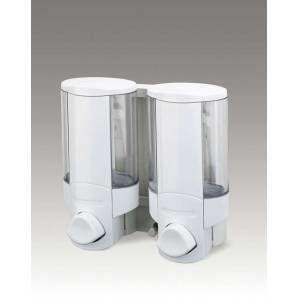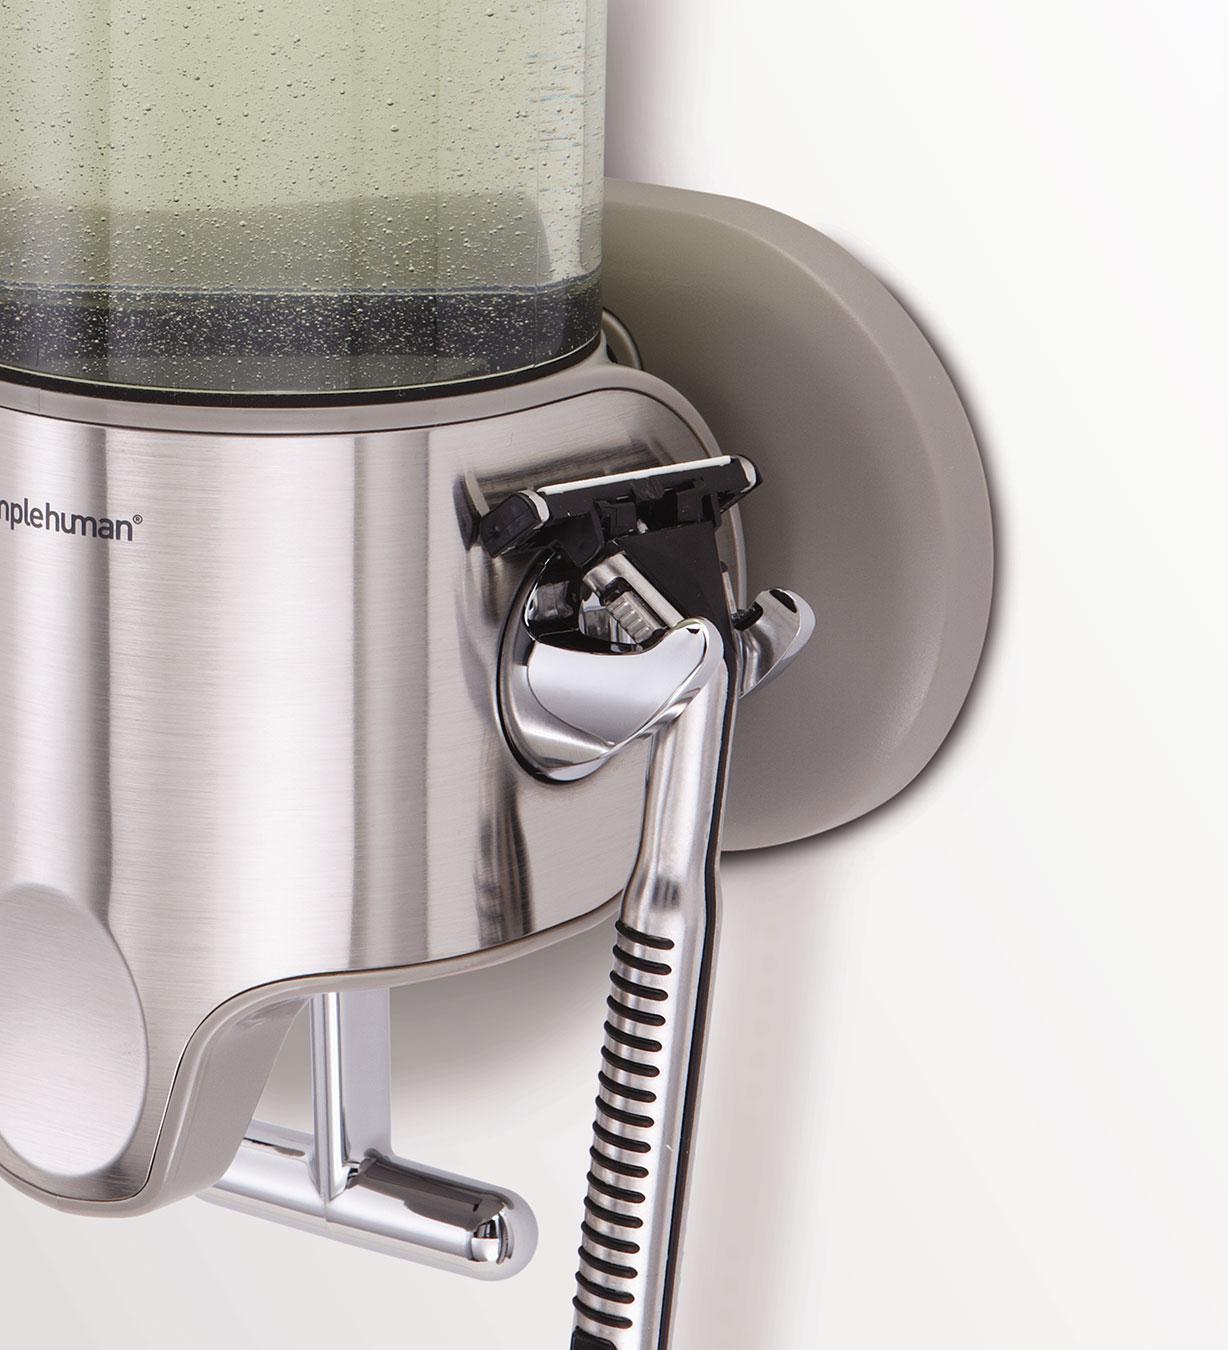The first image is the image on the left, the second image is the image on the right. Assess this claim about the two images: "There are four soap dispensers in total.". Correct or not? Answer yes or no. No. The first image is the image on the left, the second image is the image on the right. Considering the images on both sides, is "An image shows at least two side-by-side dispensers that feature a chrome T-shaped bar underneath." valid? Answer yes or no. No. 